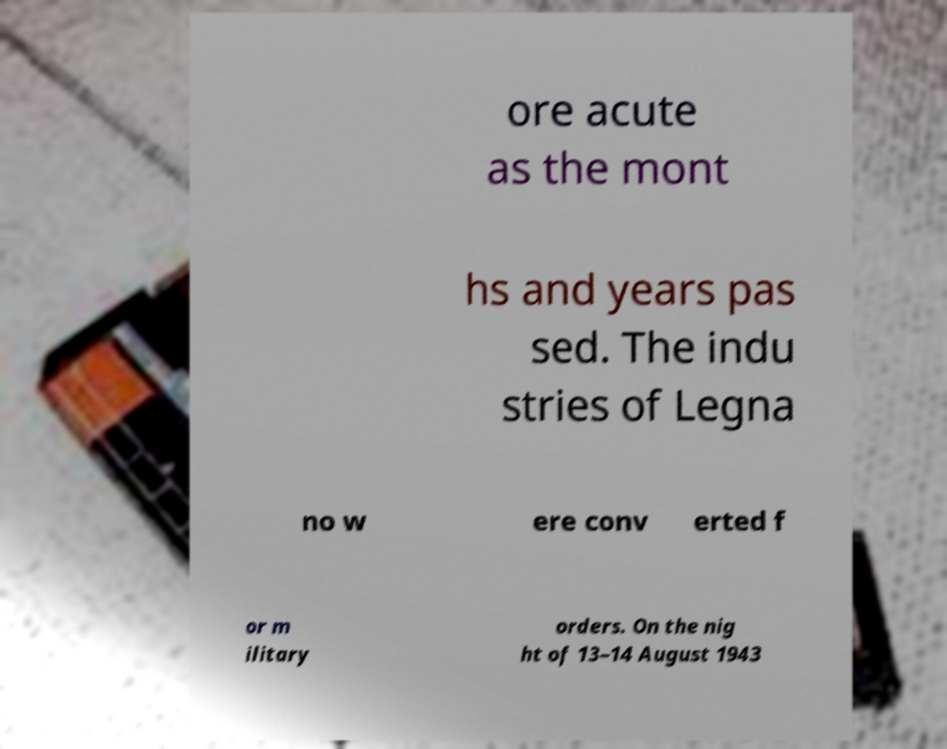What messages or text are displayed in this image? I need them in a readable, typed format. ore acute as the mont hs and years pas sed. The indu stries of Legna no w ere conv erted f or m ilitary orders. On the nig ht of 13–14 August 1943 